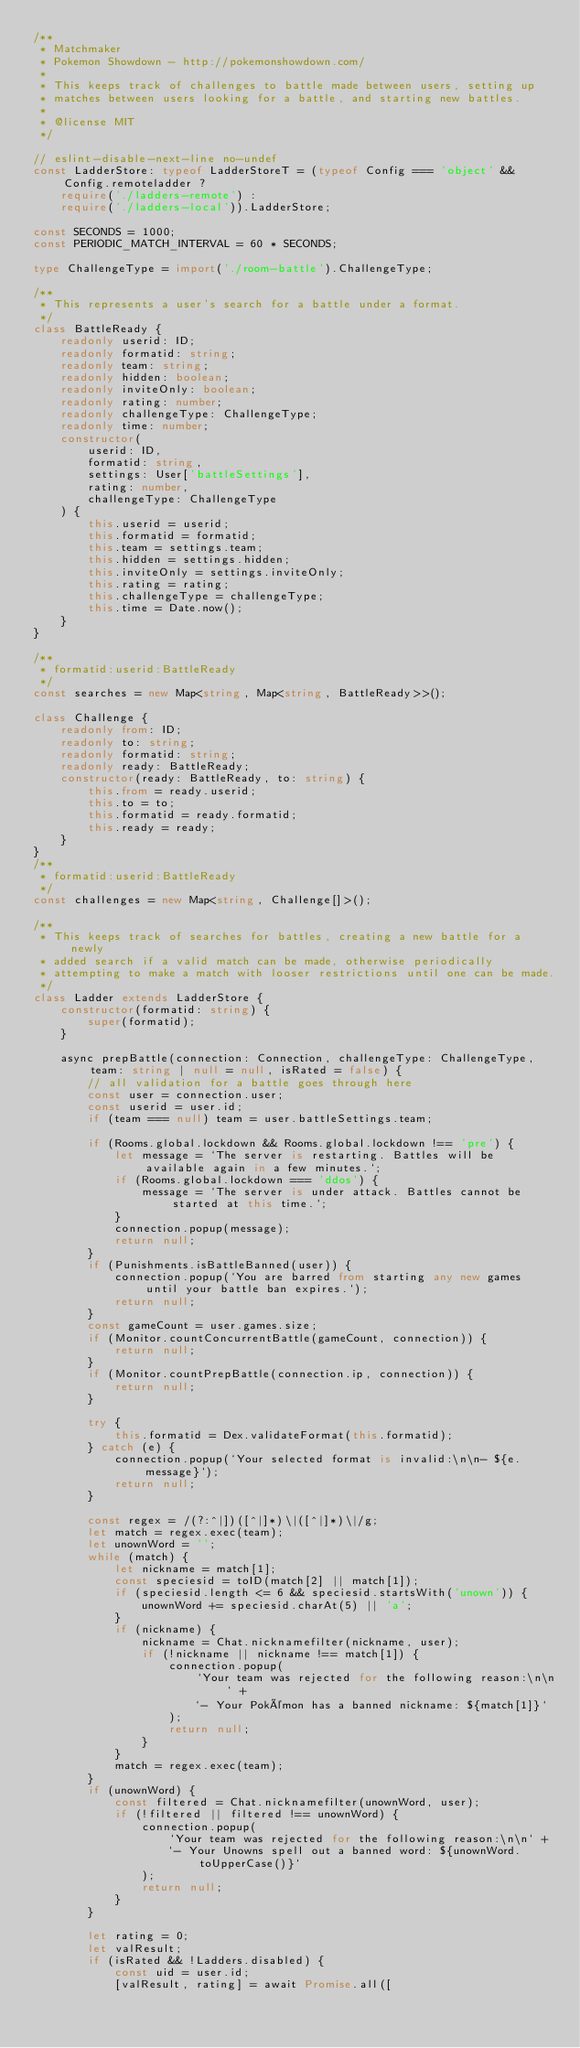<code> <loc_0><loc_0><loc_500><loc_500><_TypeScript_>/**
 * Matchmaker
 * Pokemon Showdown - http://pokemonshowdown.com/
 *
 * This keeps track of challenges to battle made between users, setting up
 * matches between users looking for a battle, and starting new battles.
 *
 * @license MIT
 */

// eslint-disable-next-line no-undef
const LadderStore: typeof LadderStoreT = (typeof Config === 'object' && Config.remoteladder ?
	require('./ladders-remote') :
	require('./ladders-local')).LadderStore;

const SECONDS = 1000;
const PERIODIC_MATCH_INTERVAL = 60 * SECONDS;

type ChallengeType = import('./room-battle').ChallengeType;

/**
 * This represents a user's search for a battle under a format.
 */
class BattleReady {
	readonly userid: ID;
	readonly formatid: string;
	readonly team: string;
	readonly hidden: boolean;
	readonly inviteOnly: boolean;
	readonly rating: number;
	readonly challengeType: ChallengeType;
	readonly time: number;
	constructor(
		userid: ID,
		formatid: string,
		settings: User['battleSettings'],
		rating: number,
		challengeType: ChallengeType
	) {
		this.userid = userid;
		this.formatid = formatid;
		this.team = settings.team;
		this.hidden = settings.hidden;
		this.inviteOnly = settings.inviteOnly;
		this.rating = rating;
		this.challengeType = challengeType;
		this.time = Date.now();
	}
}

/**
 * formatid:userid:BattleReady
 */
const searches = new Map<string, Map<string, BattleReady>>();

class Challenge {
	readonly from: ID;
	readonly to: string;
	readonly formatid: string;
	readonly ready: BattleReady;
	constructor(ready: BattleReady, to: string) {
		this.from = ready.userid;
		this.to = to;
		this.formatid = ready.formatid;
		this.ready = ready;
	}
}
/**
 * formatid:userid:BattleReady
 */
const challenges = new Map<string, Challenge[]>();

/**
 * This keeps track of searches for battles, creating a new battle for a newly
 * added search if a valid match can be made, otherwise periodically
 * attempting to make a match with looser restrictions until one can be made.
 */
class Ladder extends LadderStore {
	constructor(formatid: string) {
		super(formatid);
	}

	async prepBattle(connection: Connection, challengeType: ChallengeType, team: string | null = null, isRated = false) {
		// all validation for a battle goes through here
		const user = connection.user;
		const userid = user.id;
		if (team === null) team = user.battleSettings.team;

		if (Rooms.global.lockdown && Rooms.global.lockdown !== 'pre') {
			let message = `The server is restarting. Battles will be available again in a few minutes.`;
			if (Rooms.global.lockdown === 'ddos') {
				message = `The server is under attack. Battles cannot be started at this time.`;
			}
			connection.popup(message);
			return null;
		}
		if (Punishments.isBattleBanned(user)) {
			connection.popup(`You are barred from starting any new games until your battle ban expires.`);
			return null;
		}
		const gameCount = user.games.size;
		if (Monitor.countConcurrentBattle(gameCount, connection)) {
			return null;
		}
		if (Monitor.countPrepBattle(connection.ip, connection)) {
			return null;
		}

		try {
			this.formatid = Dex.validateFormat(this.formatid);
		} catch (e) {
			connection.popup(`Your selected format is invalid:\n\n- ${e.message}`);
			return null;
		}

		const regex = /(?:^|])([^|]*)\|([^|]*)\|/g;
		let match = regex.exec(team);
		let unownWord = '';
		while (match) {
			let nickname = match[1];
			const speciesid = toID(match[2] || match[1]);
			if (speciesid.length <= 6 && speciesid.startsWith('unown')) {
				unownWord += speciesid.charAt(5) || 'a';
			}
			if (nickname) {
				nickname = Chat.nicknamefilter(nickname, user);
				if (!nickname || nickname !== match[1]) {
					connection.popup(
						`Your team was rejected for the following reason:\n\n` +
						`- Your Pokémon has a banned nickname: ${match[1]}`
					);
					return null;
				}
			}
			match = regex.exec(team);
		}
		if (unownWord) {
			const filtered = Chat.nicknamefilter(unownWord, user);
			if (!filtered || filtered !== unownWord) {
				connection.popup(
					`Your team was rejected for the following reason:\n\n` +
					`- Your Unowns spell out a banned word: ${unownWord.toUpperCase()}`
				);
				return null;
			}
		}

		let rating = 0;
		let valResult;
		if (isRated && !Ladders.disabled) {
			const uid = user.id;
			[valResult, rating] = await Promise.all([</code> 